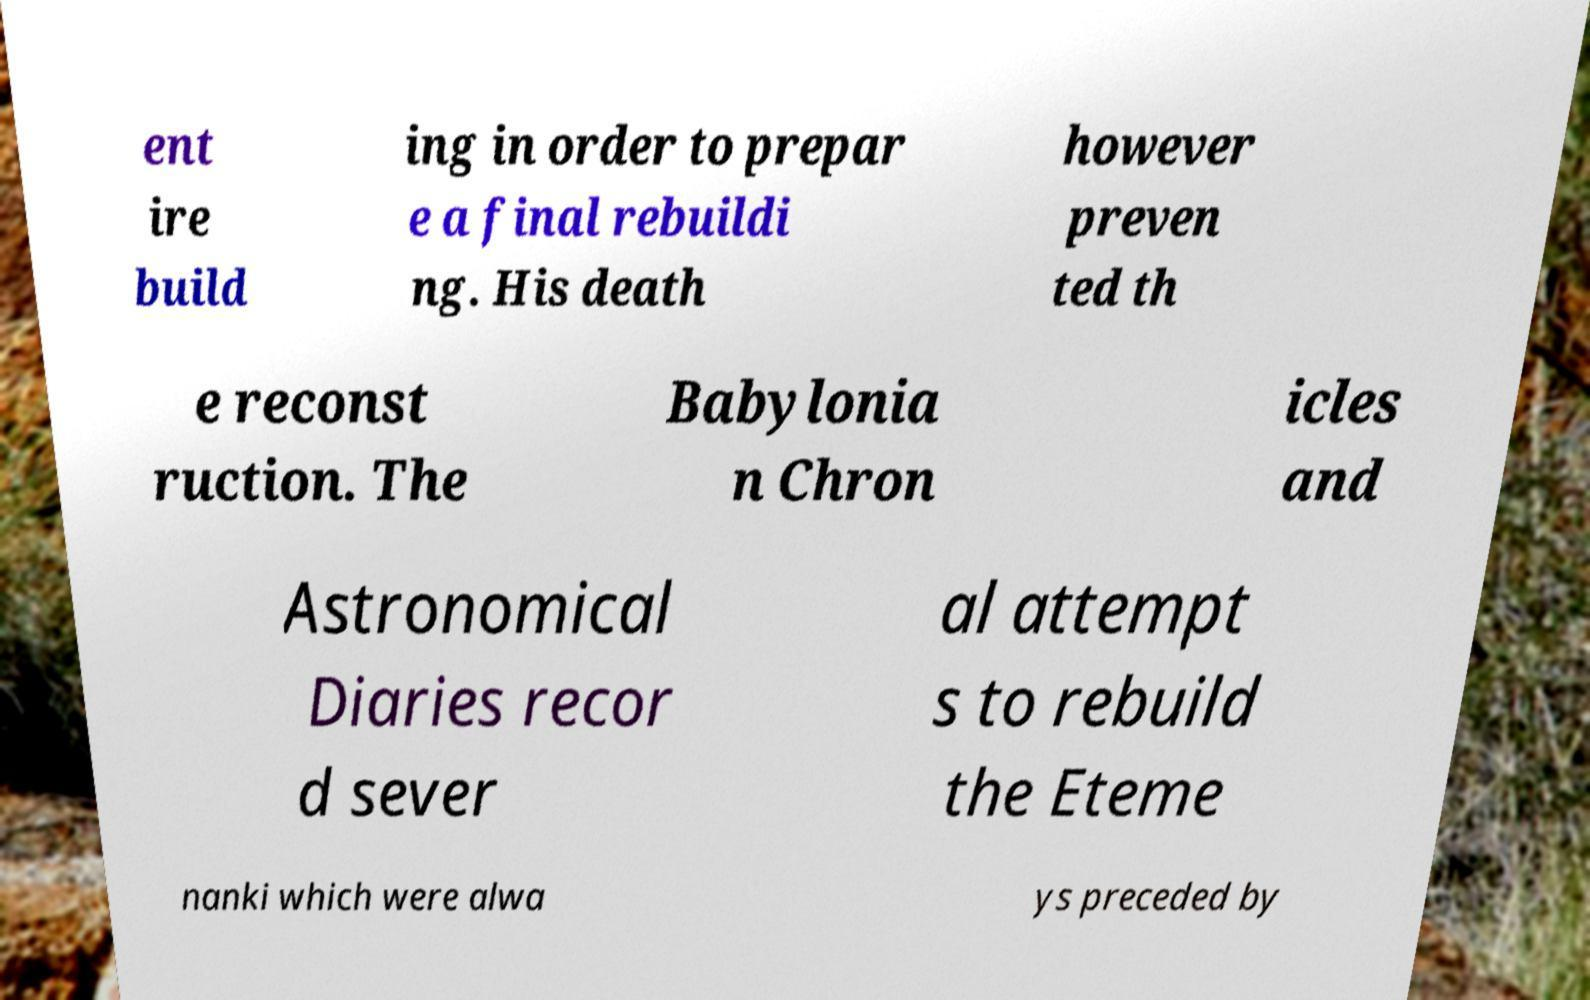Please identify and transcribe the text found in this image. ent ire build ing in order to prepar e a final rebuildi ng. His death however preven ted th e reconst ruction. The Babylonia n Chron icles and Astronomical Diaries recor d sever al attempt s to rebuild the Eteme nanki which were alwa ys preceded by 